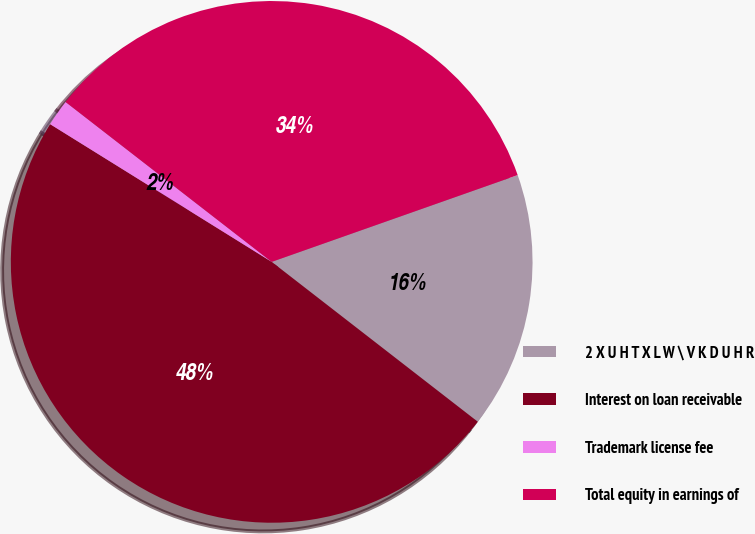Convert chart to OTSL. <chart><loc_0><loc_0><loc_500><loc_500><pie_chart><fcel>2 X U H T X L W \ V K D U H R<fcel>Interest on loan receivable<fcel>Trademark license fee<fcel>Total equity in earnings of<nl><fcel>15.9%<fcel>48.35%<fcel>1.65%<fcel>34.1%<nl></chart> 